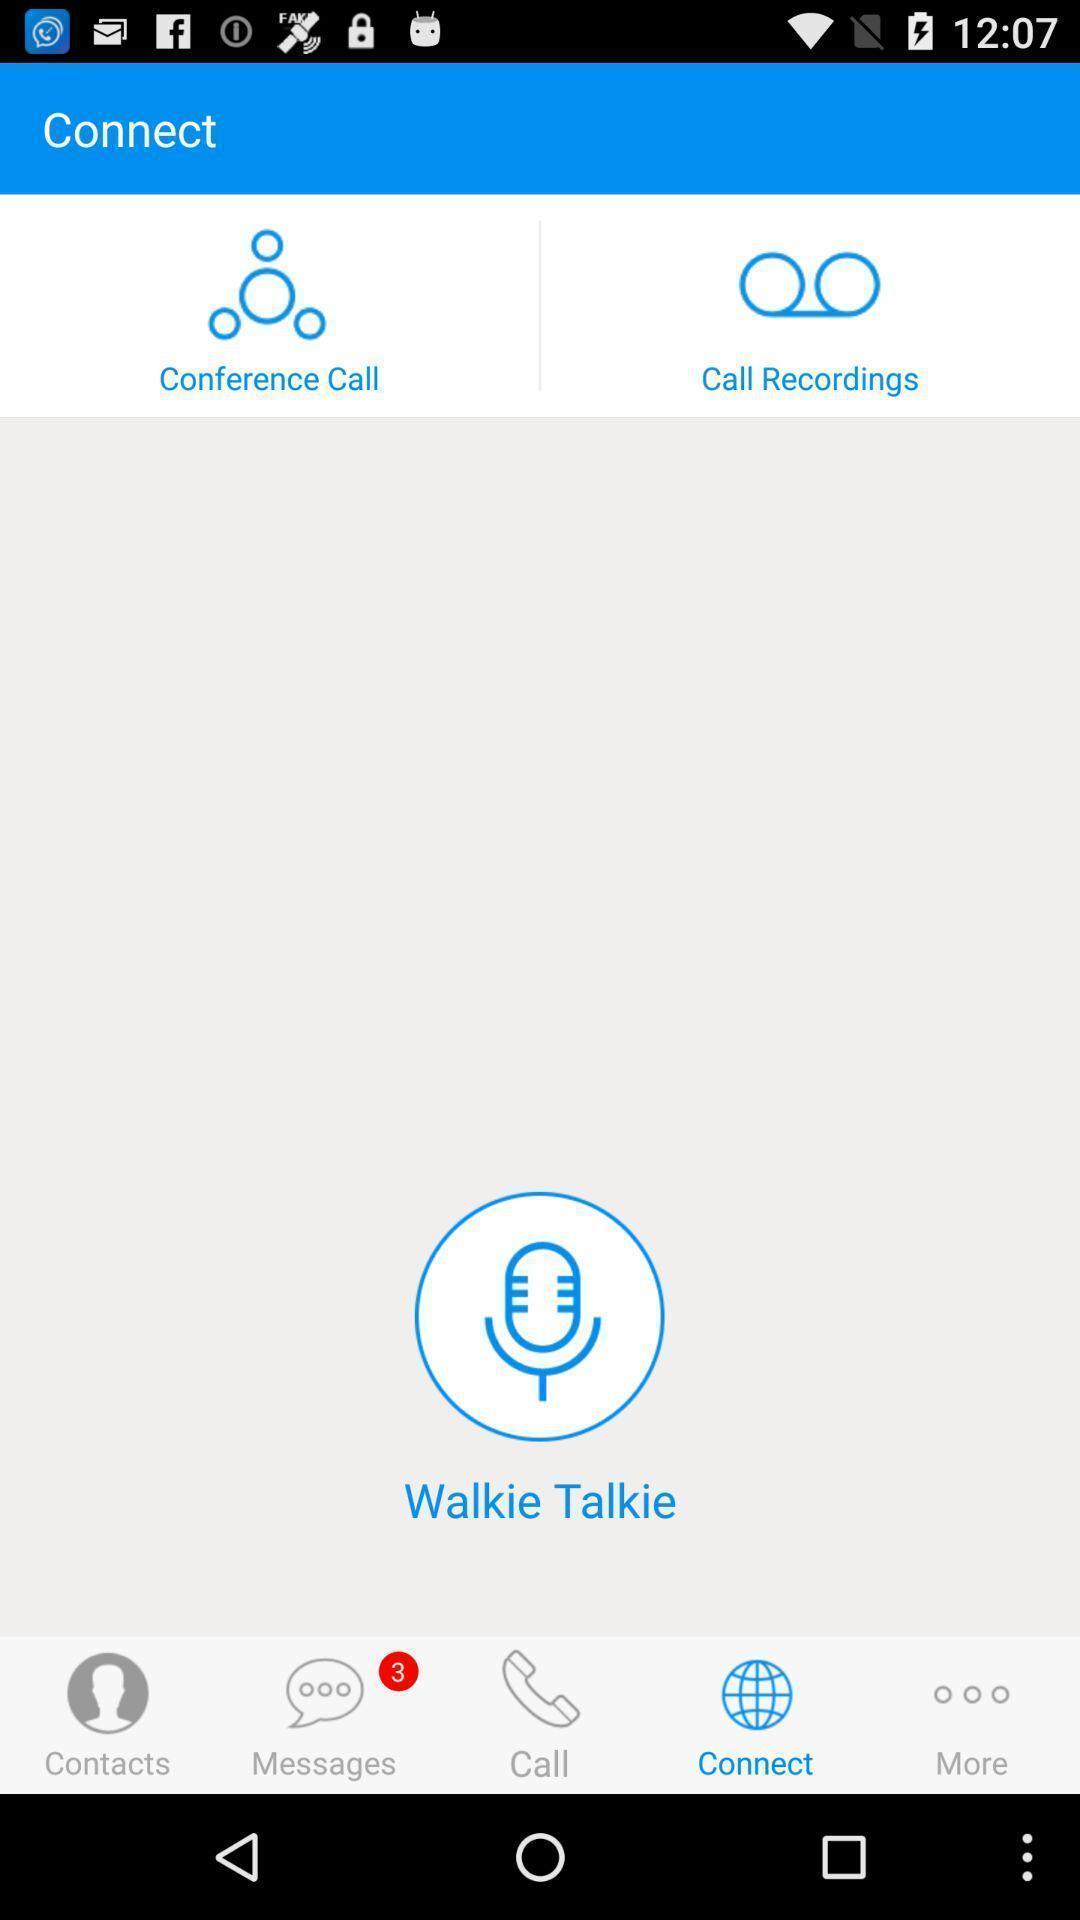Tell me about the visual elements in this screen capture. Screen shows different options. 